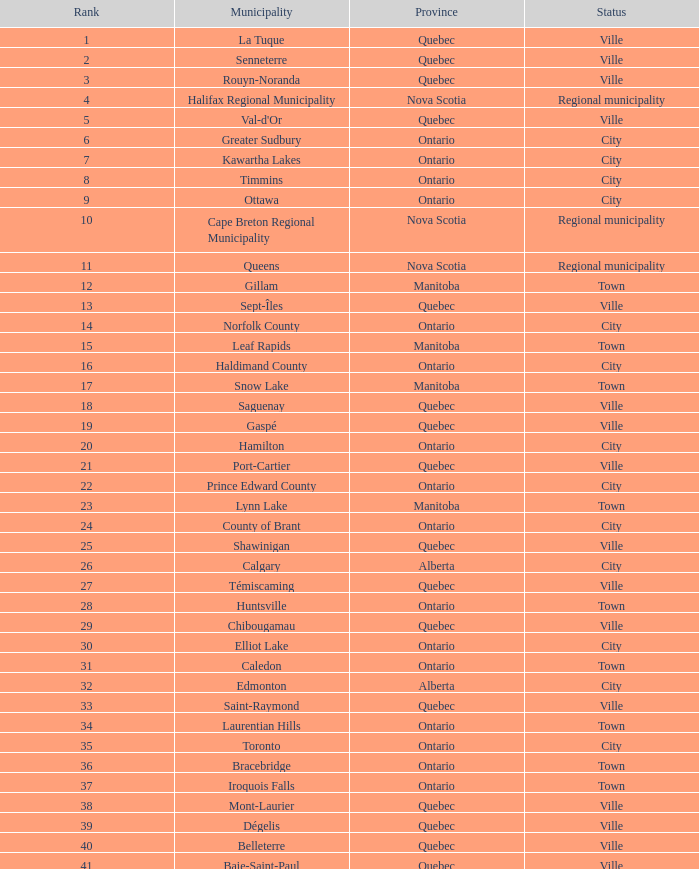What is the listed Status that has the Province of Ontario and Rank of 86? Town. Give me the full table as a dictionary. {'header': ['Rank', 'Municipality', 'Province', 'Status'], 'rows': [['1', 'La Tuque', 'Quebec', 'Ville'], ['2', 'Senneterre', 'Quebec', 'Ville'], ['3', 'Rouyn-Noranda', 'Quebec', 'Ville'], ['4', 'Halifax Regional Municipality', 'Nova Scotia', 'Regional municipality'], ['5', "Val-d'Or", 'Quebec', 'Ville'], ['6', 'Greater Sudbury', 'Ontario', 'City'], ['7', 'Kawartha Lakes', 'Ontario', 'City'], ['8', 'Timmins', 'Ontario', 'City'], ['9', 'Ottawa', 'Ontario', 'City'], ['10', 'Cape Breton Regional Municipality', 'Nova Scotia', 'Regional municipality'], ['11', 'Queens', 'Nova Scotia', 'Regional municipality'], ['12', 'Gillam', 'Manitoba', 'Town'], ['13', 'Sept-Îles', 'Quebec', 'Ville'], ['14', 'Norfolk County', 'Ontario', 'City'], ['15', 'Leaf Rapids', 'Manitoba', 'Town'], ['16', 'Haldimand County', 'Ontario', 'City'], ['17', 'Snow Lake', 'Manitoba', 'Town'], ['18', 'Saguenay', 'Quebec', 'Ville'], ['19', 'Gaspé', 'Quebec', 'Ville'], ['20', 'Hamilton', 'Ontario', 'City'], ['21', 'Port-Cartier', 'Quebec', 'Ville'], ['22', 'Prince Edward County', 'Ontario', 'City'], ['23', 'Lynn Lake', 'Manitoba', 'Town'], ['24', 'County of Brant', 'Ontario', 'City'], ['25', 'Shawinigan', 'Quebec', 'Ville'], ['26', 'Calgary', 'Alberta', 'City'], ['27', 'Témiscaming', 'Quebec', 'Ville'], ['28', 'Huntsville', 'Ontario', 'Town'], ['29', 'Chibougamau', 'Quebec', 'Ville'], ['30', 'Elliot Lake', 'Ontario', 'City'], ['31', 'Caledon', 'Ontario', 'Town'], ['32', 'Edmonton', 'Alberta', 'City'], ['33', 'Saint-Raymond', 'Quebec', 'Ville'], ['34', 'Laurentian Hills', 'Ontario', 'Town'], ['35', 'Toronto', 'Ontario', 'City'], ['36', 'Bracebridge', 'Ontario', 'Town'], ['37', 'Iroquois Falls', 'Ontario', 'Town'], ['38', 'Mont-Laurier', 'Quebec', 'Ville'], ['39', 'Dégelis', 'Quebec', 'Ville'], ['40', 'Belleterre', 'Quebec', 'Ville'], ['41', 'Baie-Saint-Paul', 'Quebec', 'Ville'], ['42', 'Cochrane', 'Ontario', 'Town'], ['43', 'South Bruce Peninsula', 'Ontario', 'Town'], ['44', 'Lakeshore', 'Ontario', 'Town'], ['45', 'Kearney', 'Ontario', 'Town'], ['46', 'Blind River', 'Ontario', 'Town'], ['47', 'Gravenhurst', 'Ontario', 'Town'], ['48', 'Mississippi Mills', 'Ontario', 'Town'], ['49', 'Northeastern Manitoulin and the Islands', 'Ontario', 'Town'], ['50', 'Quinte West', 'Ontario', 'City'], ['51', 'Mirabel', 'Quebec', 'Ville'], ['52', 'Fermont', 'Quebec', 'Ville'], ['53', 'Winnipeg', 'Manitoba', 'City'], ['54', 'Greater Napanee', 'Ontario', 'Town'], ['55', 'La Malbaie', 'Quebec', 'Ville'], ['56', 'Rivière-Rouge', 'Quebec', 'Ville'], ['57', 'Québec City', 'Quebec', 'Ville'], ['58', 'Kingston', 'Ontario', 'City'], ['59', 'Lévis', 'Quebec', 'Ville'], ['60', "St. John's", 'Newfoundland and Labrador', 'City'], ['61', 'Bécancour', 'Quebec', 'Ville'], ['62', 'Percé', 'Quebec', 'Ville'], ['63', 'Amos', 'Quebec', 'Ville'], ['64', 'London', 'Ontario', 'City'], ['65', 'Chandler', 'Quebec', 'Ville'], ['66', 'Whitehorse', 'Yukon', 'City'], ['67', 'Gracefield', 'Quebec', 'Ville'], ['68', 'Baie Verte', 'Newfoundland and Labrador', 'Town'], ['69', 'Milton', 'Ontario', 'Town'], ['70', 'Montreal', 'Quebec', 'Ville'], ['71', 'Saint-Félicien', 'Quebec', 'Ville'], ['72', 'Abbotsford', 'British Columbia', 'City'], ['73', 'Sherbrooke', 'Quebec', 'Ville'], ['74', 'Gatineau', 'Quebec', 'Ville'], ['75', 'Pohénégamook', 'Quebec', 'Ville'], ['76', 'Baie-Comeau', 'Quebec', 'Ville'], ['77', 'Thunder Bay', 'Ontario', 'City'], ['78', 'Plympton–Wyoming', 'Ontario', 'Town'], ['79', 'Surrey', 'British Columbia', 'City'], ['80', 'Prince George', 'British Columbia', 'City'], ['81', 'Saint John', 'New Brunswick', 'City'], ['82', 'North Bay', 'Ontario', 'City'], ['83', 'Happy Valley-Goose Bay', 'Newfoundland and Labrador', 'Town'], ['84', 'Minto', 'Ontario', 'Town'], ['85', 'Kamloops', 'British Columbia', 'City'], ['86', 'Erin', 'Ontario', 'Town'], ['87', 'Clarence-Rockland', 'Ontario', 'City'], ['88', 'Cookshire-Eaton', 'Quebec', 'Ville'], ['89', 'Dolbeau-Mistassini', 'Quebec', 'Ville'], ['90', 'Trois-Rivières', 'Quebec', 'Ville'], ['91', 'Mississauga', 'Ontario', 'City'], ['92', 'Georgina', 'Ontario', 'Town'], ['93', 'The Blue Mountains', 'Ontario', 'Town'], ['94', 'Innisfil', 'Ontario', 'Town'], ['95', 'Essex', 'Ontario', 'Town'], ['96', 'Mono', 'Ontario', 'Town'], ['97', 'Halton Hills', 'Ontario', 'Town'], ['98', 'New Tecumseth', 'Ontario', 'Town'], ['99', 'Vaughan', 'Ontario', 'City'], ['100', 'Brampton', 'Ontario', 'City']]} 